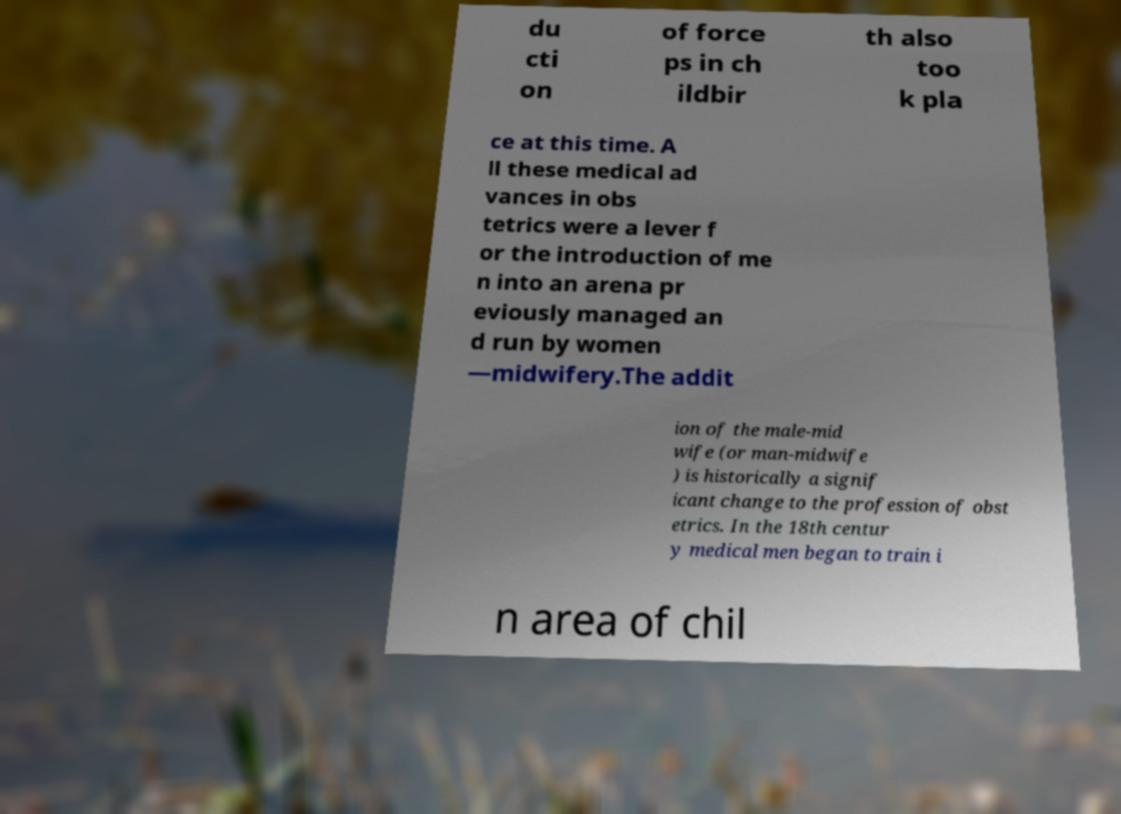Please identify and transcribe the text found in this image. du cti on of force ps in ch ildbir th also too k pla ce at this time. A ll these medical ad vances in obs tetrics were a lever f or the introduction of me n into an arena pr eviously managed an d run by women —midwifery.The addit ion of the male-mid wife (or man-midwife ) is historically a signif icant change to the profession of obst etrics. In the 18th centur y medical men began to train i n area of chil 